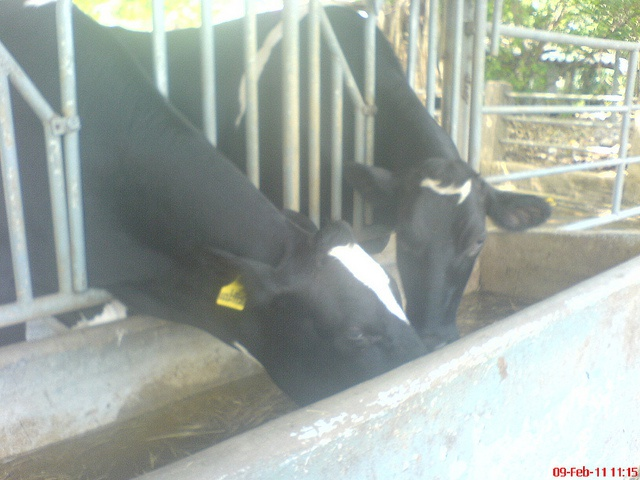Describe the objects in this image and their specific colors. I can see cow in darkgray, gray, and white tones and cow in darkgray and gray tones in this image. 